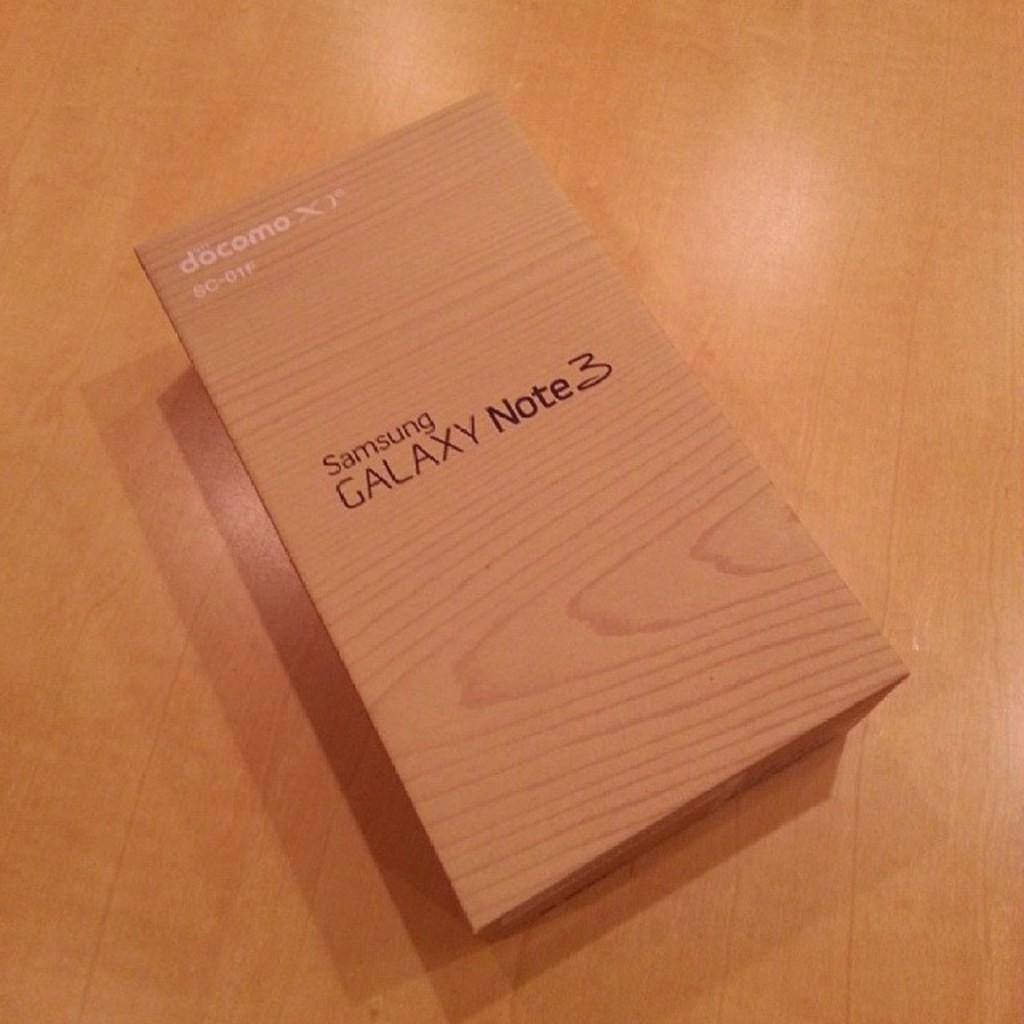<image>
Provide a brief description of the given image. The box sitting on the table contains a Samsung Galaxy Note. 